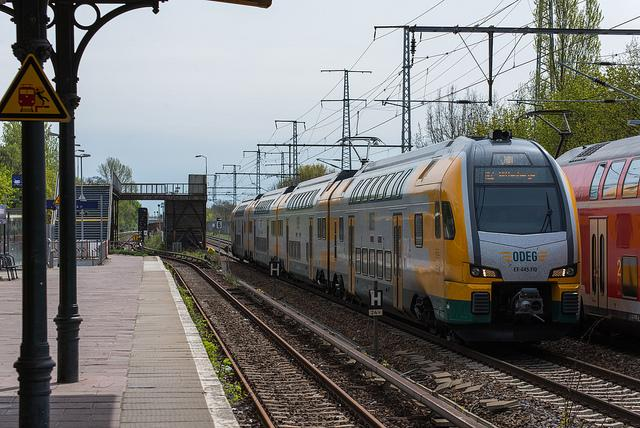What number is on the red train? Please explain your reasoning. two. The number is 2. 